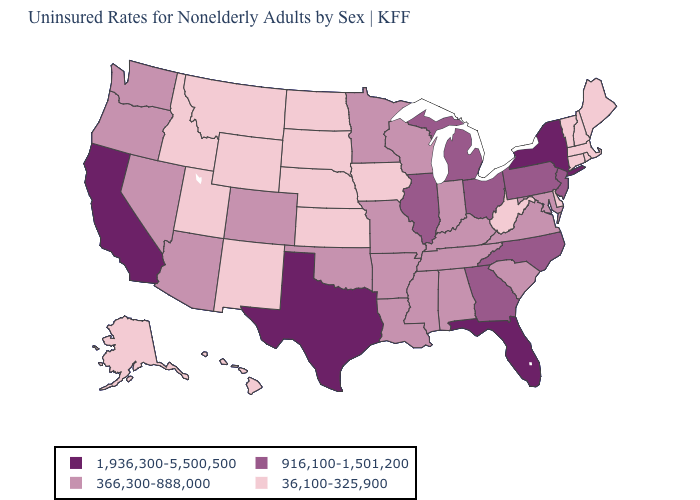Does New York have the highest value in the Northeast?
Concise answer only. Yes. What is the value of Maryland?
Be succinct. 366,300-888,000. Among the states that border Louisiana , does Texas have the lowest value?
Keep it brief. No. What is the value of Idaho?
Keep it brief. 36,100-325,900. Among the states that border Indiana , which have the lowest value?
Keep it brief. Kentucky. Does Nebraska have the lowest value in the MidWest?
Keep it brief. Yes. Does Oregon have the highest value in the West?
Write a very short answer. No. Name the states that have a value in the range 1,936,300-5,500,500?
Write a very short answer. California, Florida, New York, Texas. Which states have the lowest value in the USA?
Quick response, please. Alaska, Connecticut, Delaware, Hawaii, Idaho, Iowa, Kansas, Maine, Massachusetts, Montana, Nebraska, New Hampshire, New Mexico, North Dakota, Rhode Island, South Dakota, Utah, Vermont, West Virginia, Wyoming. What is the value of Montana?
Answer briefly. 36,100-325,900. Among the states that border Oregon , which have the highest value?
Answer briefly. California. Name the states that have a value in the range 916,100-1,501,200?
Concise answer only. Georgia, Illinois, Michigan, New Jersey, North Carolina, Ohio, Pennsylvania. What is the highest value in the USA?
Short answer required. 1,936,300-5,500,500. Name the states that have a value in the range 916,100-1,501,200?
Answer briefly. Georgia, Illinois, Michigan, New Jersey, North Carolina, Ohio, Pennsylvania. Name the states that have a value in the range 36,100-325,900?
Concise answer only. Alaska, Connecticut, Delaware, Hawaii, Idaho, Iowa, Kansas, Maine, Massachusetts, Montana, Nebraska, New Hampshire, New Mexico, North Dakota, Rhode Island, South Dakota, Utah, Vermont, West Virginia, Wyoming. 